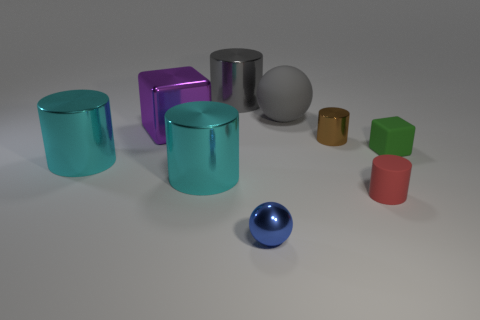Is the color of the big shiny cube the same as the metallic sphere?
Your answer should be very brief. No. What shape is the thing that is the same color as the rubber ball?
Offer a terse response. Cylinder. There is a thing behind the large gray object right of the large gray metallic object; what size is it?
Your response must be concise. Large. How many things are objects to the left of the tiny blue metal ball or cylinders that are right of the purple metal object?
Offer a terse response. 6. Is the number of large red shiny spheres less than the number of green rubber things?
Your response must be concise. Yes. How many objects are either small metallic blocks or small green blocks?
Ensure brevity in your answer.  1. Is the shape of the green rubber object the same as the small blue shiny thing?
Offer a very short reply. No. Are there any other things that have the same material as the tiny ball?
Give a very brief answer. Yes. There is a ball behind the small green rubber block; is its size the same as the cylinder that is behind the large ball?
Your response must be concise. Yes. What is the material of the large thing that is both on the right side of the purple metallic object and in front of the tiny green matte object?
Ensure brevity in your answer.  Metal. 